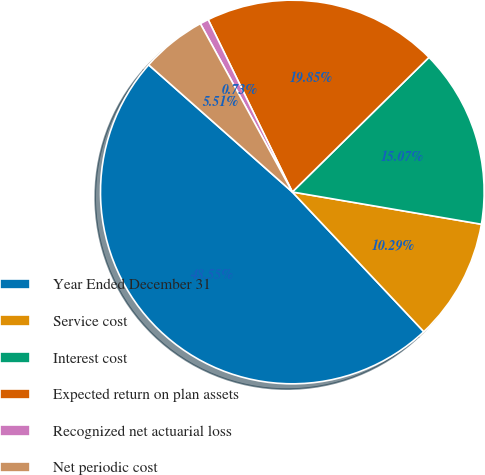<chart> <loc_0><loc_0><loc_500><loc_500><pie_chart><fcel>Year Ended December 31<fcel>Service cost<fcel>Interest cost<fcel>Expected return on plan assets<fcel>Recognized net actuarial loss<fcel>Net periodic cost<nl><fcel>48.55%<fcel>10.29%<fcel>15.07%<fcel>19.85%<fcel>0.73%<fcel>5.51%<nl></chart> 